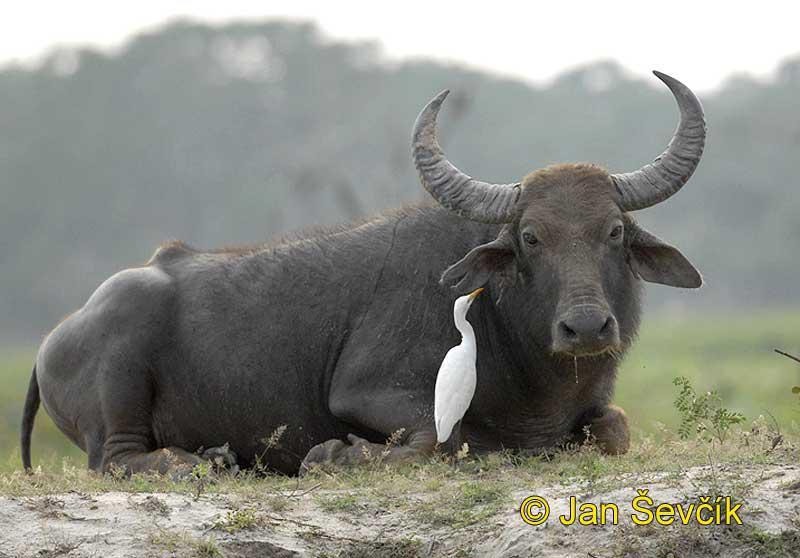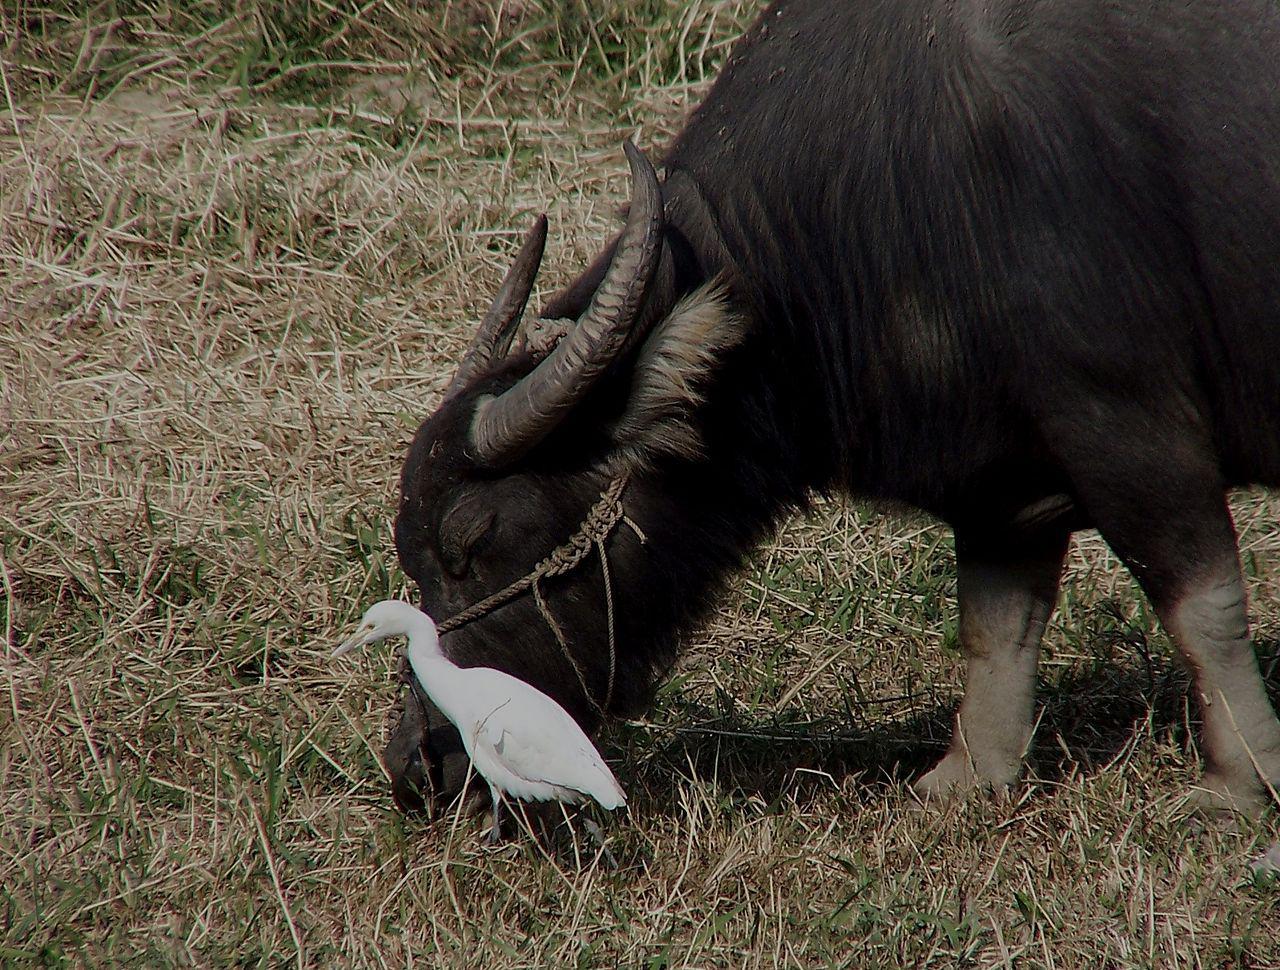The first image is the image on the left, the second image is the image on the right. Considering the images on both sides, is "Two animals are standing in the water." valid? Answer yes or no. No. 